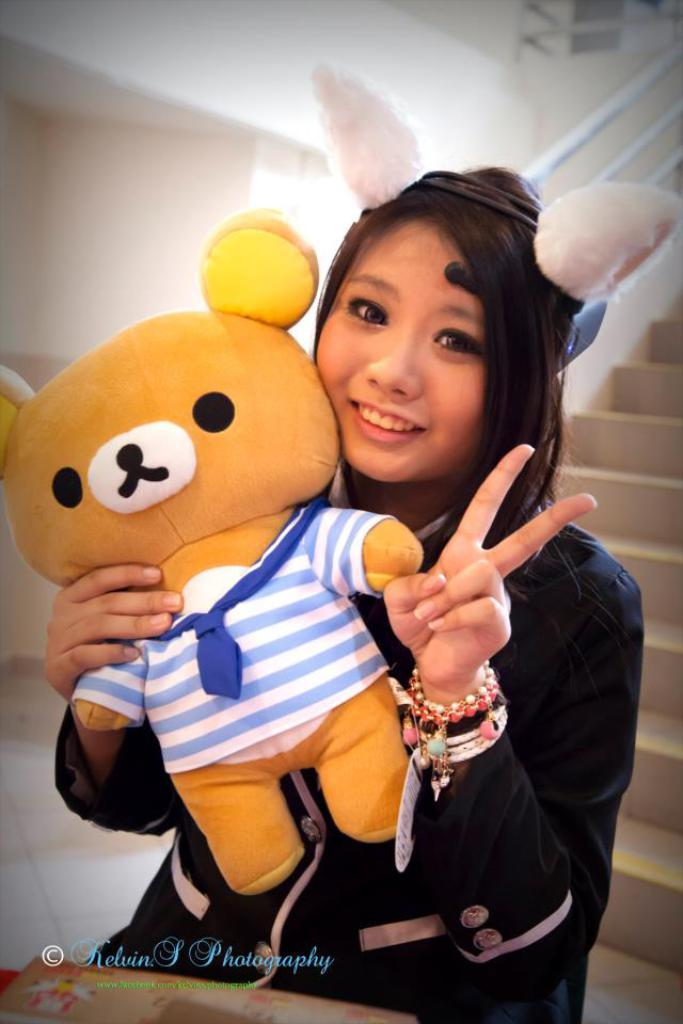Who is present in the image? There is a woman in the image. What is the woman holding in the image? The woman is holding a toy. What architectural feature is visible behind the woman? There are steps behind the woman, and a wall is visible behind the steps. What type of pets are visible in the image? There are no pets visible in the image. What vegetable is the woman holding in the image? The woman is holding a toy, not a vegetable like celery. 